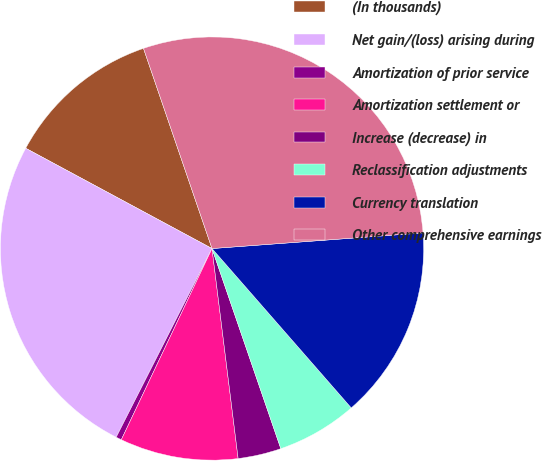<chart> <loc_0><loc_0><loc_500><loc_500><pie_chart><fcel>(In thousands)<fcel>Net gain/(loss) arising during<fcel>Amortization of prior service<fcel>Amortization settlement or<fcel>Increase (decrease) in<fcel>Reclassification adjustments<fcel>Currency translation<fcel>Other comprehensive earnings<nl><fcel>11.89%<fcel>25.38%<fcel>0.43%<fcel>9.02%<fcel>3.3%<fcel>6.16%<fcel>14.75%<fcel>29.07%<nl></chart> 